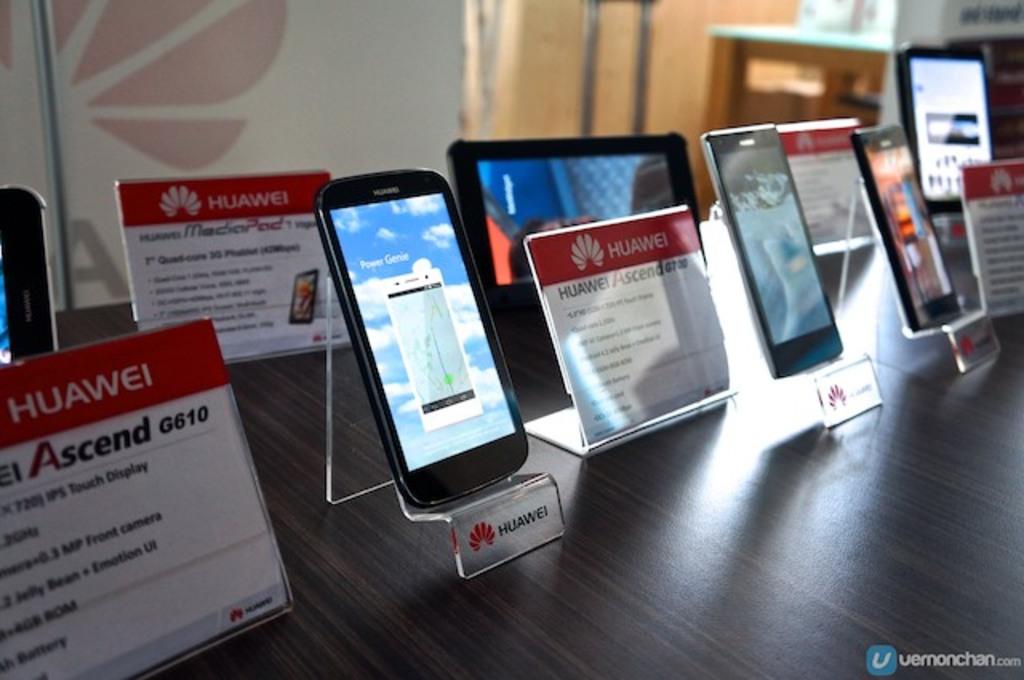What is the product number on the first information card?
Offer a very short reply. G610. What brand of phones are these?
Provide a succinct answer. Huawei. 